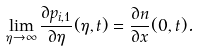<formula> <loc_0><loc_0><loc_500><loc_500>\lim _ { \eta \to \infty } \frac { \partial p _ { i , 1 } } { \partial \eta } ( \eta , t ) = \frac { \partial n } { \partial x } ( 0 , t ) .</formula> 